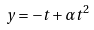Convert formula to latex. <formula><loc_0><loc_0><loc_500><loc_500>y = - t + \alpha t ^ { 2 }</formula> 